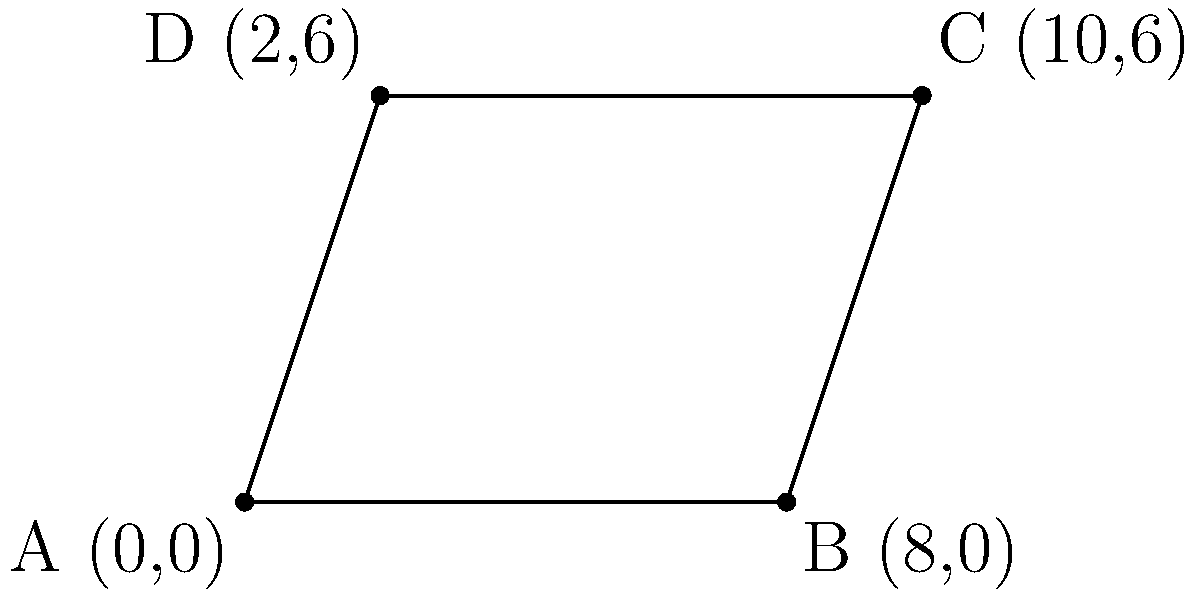As part of your research on dance floor designs, you need to calculate the area of an irregularly shaped dance floor. The corners of the dance floor are represented by the following coordinates: A(0,0), B(8,0), C(10,6), and D(2,6). Using the shoelace formula (also known as the surveyor's formula), calculate the area of this dance floor in square units. To solve this problem, we'll use the shoelace formula, which is particularly useful for calculating the area of a polygon given the coordinates of its vertices. The formula is:

$$ \text{Area} = \frac{1}{2}|(x_1y_2 + x_2y_3 + ... + x_ny_1) - (y_1x_2 + y_2x_3 + ... + y_nx_1)| $$

Where $(x_i, y_i)$ are the coordinates of the $i$-th vertex.

Let's apply this to our dance floor:

1) First, let's list our coordinates in order:
   A(0,0), B(8,0), C(10,6), D(2,6)

2) Now, let's calculate the first part of the formula:
   $x_1y_2 + x_2y_3 + x_3y_4 + x_4y_1$
   $= (0 \cdot 0) + (8 \cdot 6) + (10 \cdot 6) + (2 \cdot 0) = 48 + 60 = 108$

3) Next, let's calculate the second part:
   $y_1x_2 + y_2x_3 + y_3x_4 + y_4x_1$
   $= (0 \cdot 8) + (0 \cdot 10) + (6 \cdot 2) + (6 \cdot 0) = 12$

4) Now, we subtract the second part from the first:
   $108 - 12 = 96$

5) Finally, we take the absolute value and divide by 2:
   $\text{Area} = \frac{1}{2}|96| = 48$

Therefore, the area of the dance floor is 48 square units.
Answer: 48 square units 